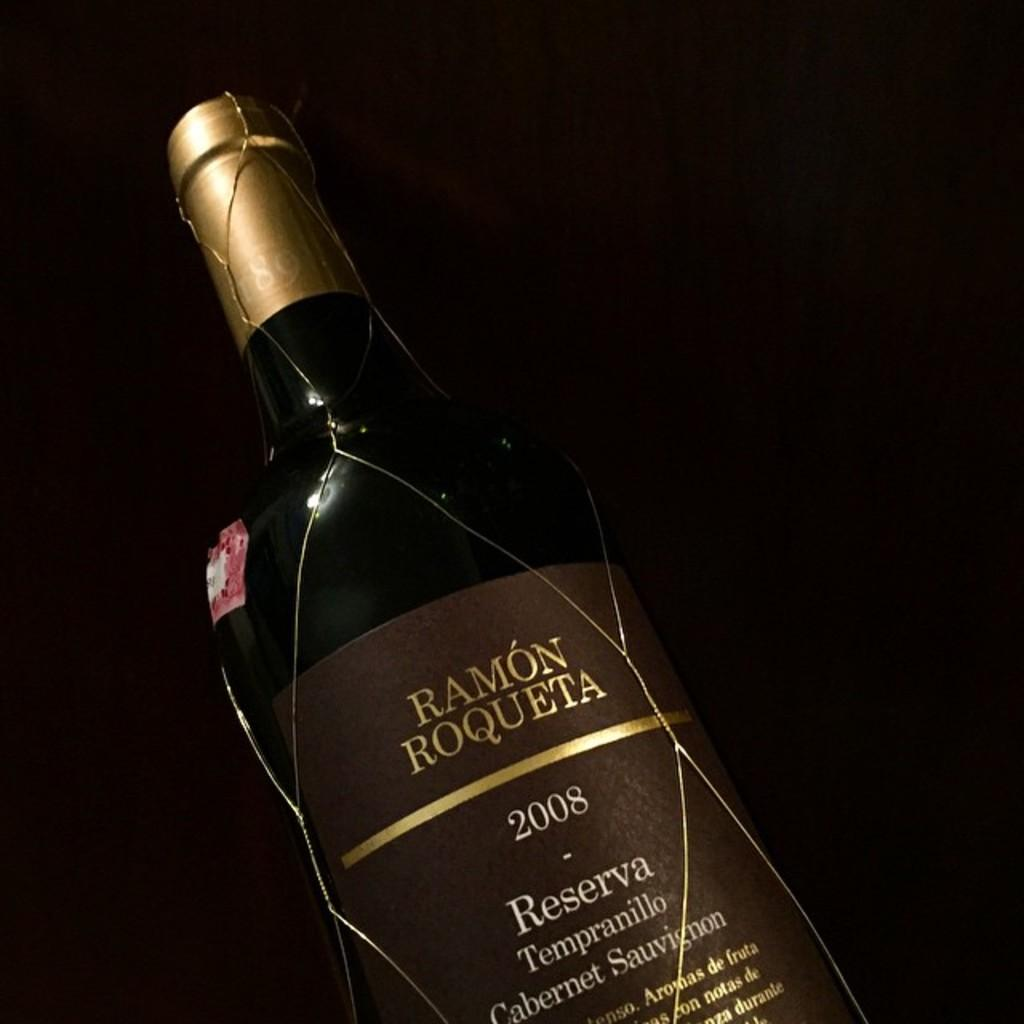<image>
Give a short and clear explanation of the subsequent image. A bottle of Ramon Roqueta alcohol from 2008. 